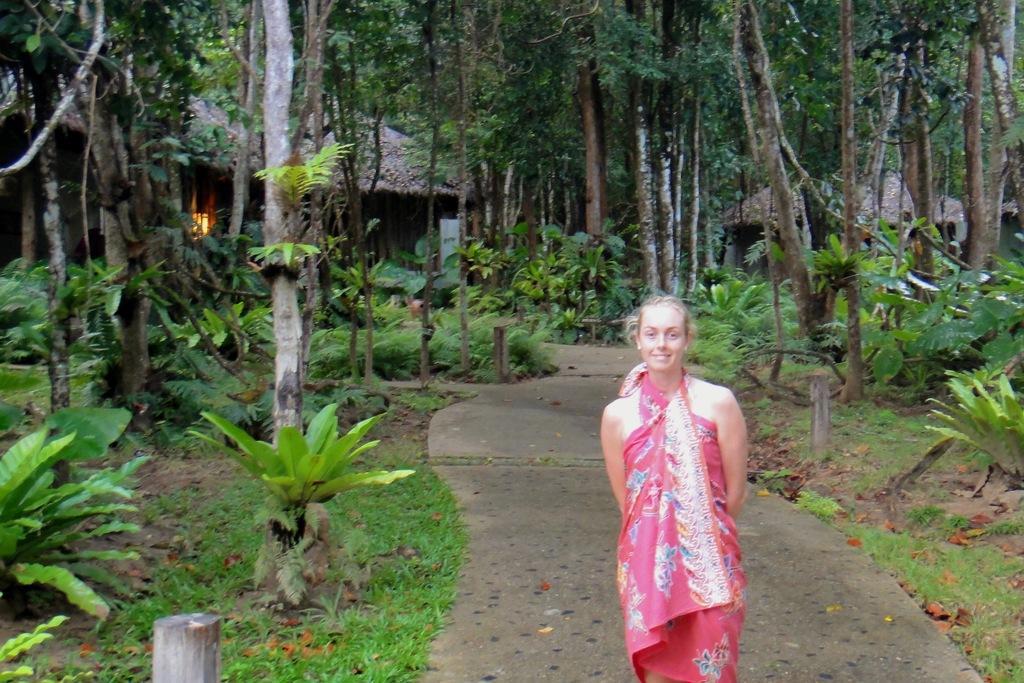Please provide a concise description of this image. There is one girl standing on the road as we can see at the bottom of this image and there are some trees in the background. 